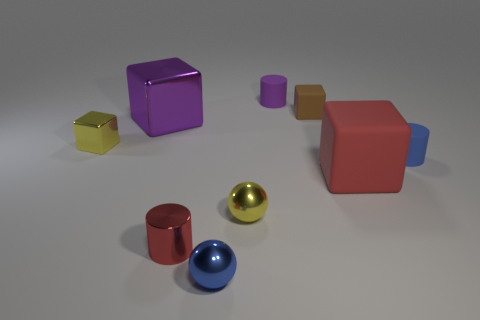What size is the object that is right of the small blue shiny ball and in front of the red matte thing?
Ensure brevity in your answer.  Small. There is a tiny yellow thing in front of the shiny cube that is to the left of the large purple object; how many small yellow metal objects are behind it?
Your response must be concise. 1. Are there any matte objects that have the same color as the tiny shiny cylinder?
Offer a very short reply. Yes. The shiny cylinder that is the same size as the yellow metal block is what color?
Your response must be concise. Red. What is the shape of the blue object to the left of the purple thing on the right side of the blue thing that is in front of the large red matte thing?
Offer a terse response. Sphere. There is a small blue thing on the right side of the purple rubber thing; how many brown matte objects are to the right of it?
Your answer should be very brief. 0. There is a tiny rubber thing that is on the right side of the small brown cube; is its shape the same as the tiny rubber thing behind the small brown rubber block?
Offer a terse response. Yes. How many big red objects are to the right of the large red object?
Make the answer very short. 0. Do the small yellow thing that is on the right side of the red metallic object and the small purple cylinder have the same material?
Provide a succinct answer. No. What color is the other tiny thing that is the same shape as the small brown rubber thing?
Ensure brevity in your answer.  Yellow. 